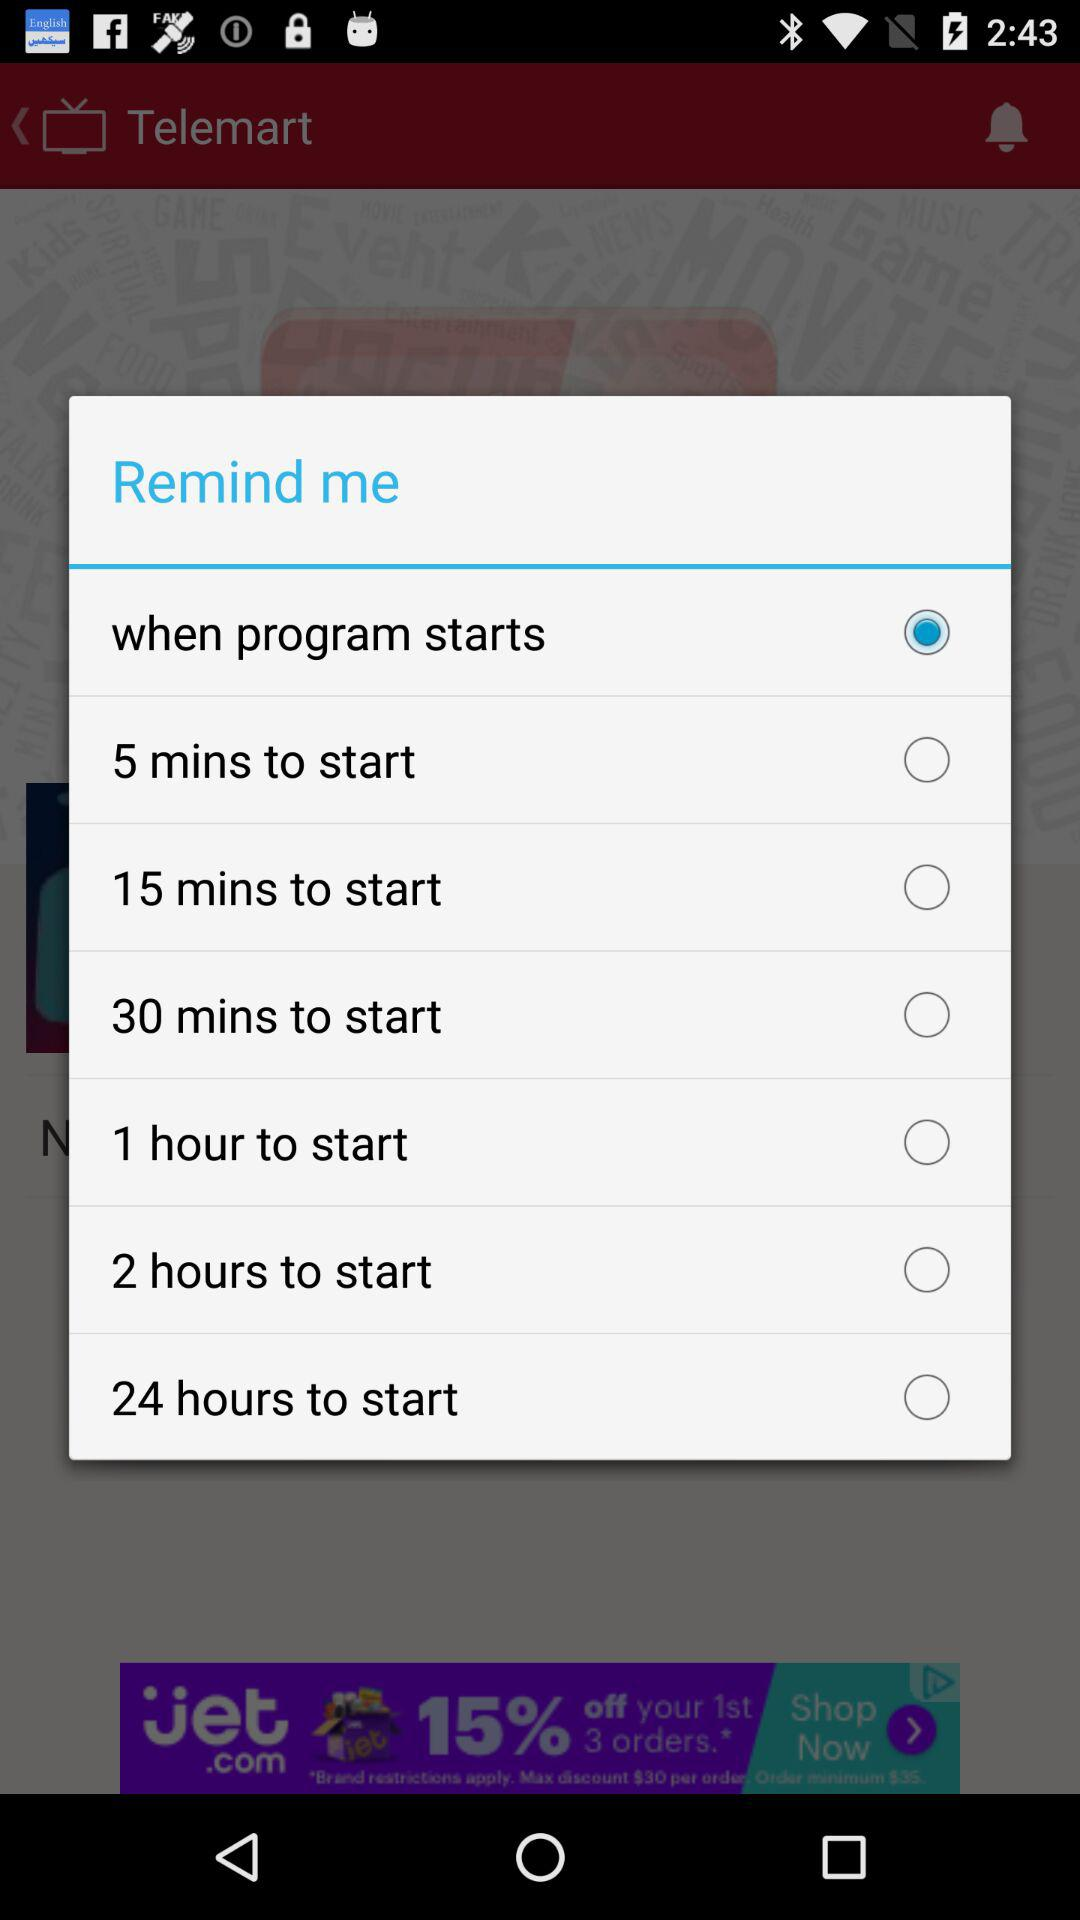How many hours longer is the 24 hour reminder than the 1 hour reminder?
Answer the question using a single word or phrase. 23 